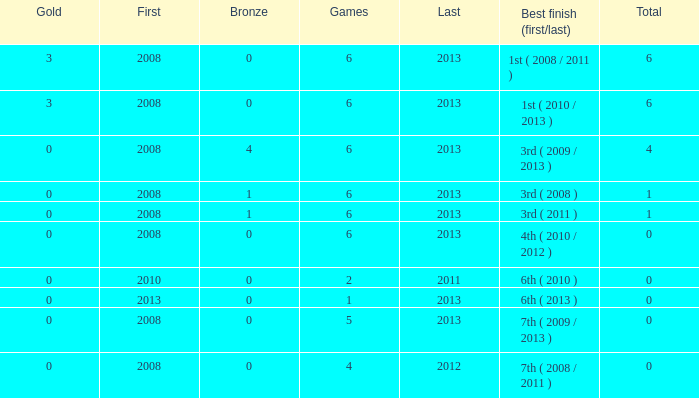How many games are associated with over 0 golds and a first year before 2008? None. 